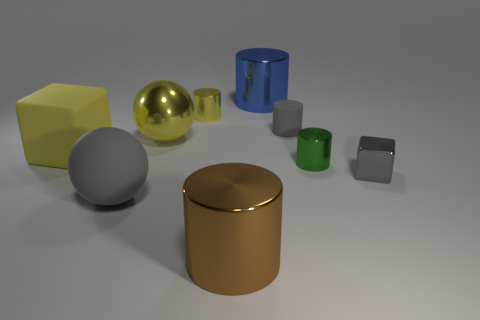How many other things are the same color as the metallic block?
Give a very brief answer. 2. There is a cube that is the same color as the small rubber object; what is it made of?
Your response must be concise. Metal. Do the gray matte thing that is right of the gray ball and the gray rubber thing to the left of the large brown cylinder have the same size?
Provide a succinct answer. No. What is the shape of the metallic object right of the small green metallic cylinder?
Provide a succinct answer. Cube. There is a gray thing that is the same shape as the green object; what material is it?
Offer a very short reply. Rubber. There is a block that is to the left of the gray sphere; does it have the same size as the blue metal thing?
Provide a succinct answer. Yes. There is a gray rubber cylinder; what number of metallic cylinders are behind it?
Give a very brief answer. 2. Is the number of yellow shiny cylinders in front of the tiny matte cylinder less than the number of gray rubber cylinders that are to the left of the green cylinder?
Your answer should be compact. Yes. How many big red things are there?
Give a very brief answer. 0. There is a big metal cylinder behind the tiny gray rubber thing; what color is it?
Ensure brevity in your answer.  Blue. 